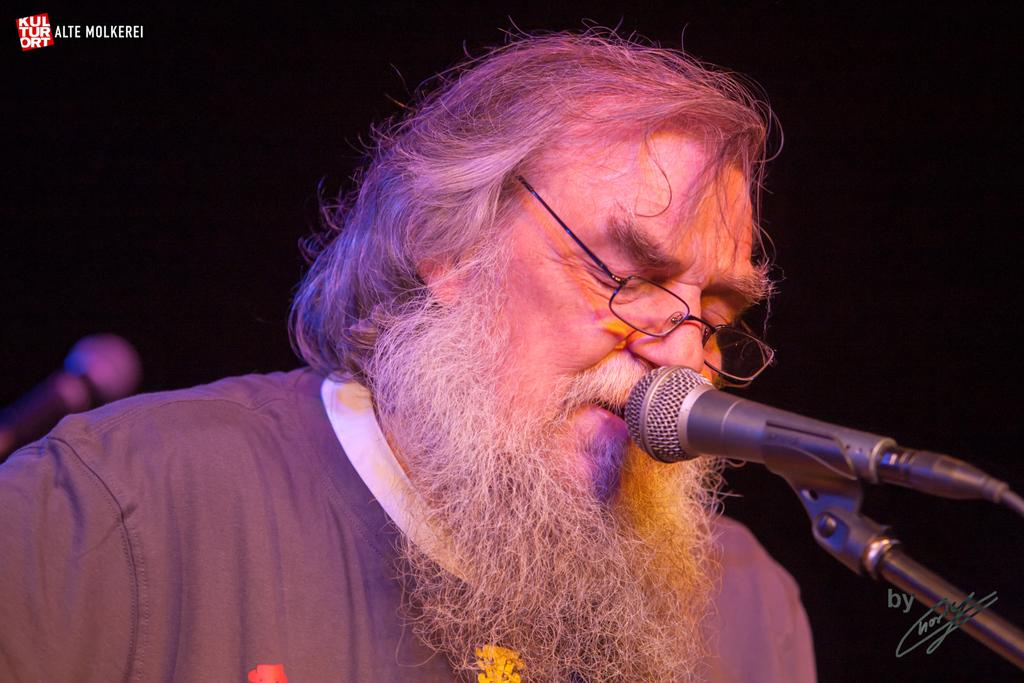Who or what is present in the image? There is a person in the image. Can you describe the person's appearance? The person is wearing spectacles. What object can be seen near the person? There is a microphone in the image. How would you describe the background of the image? The background of the image is blurred. What type of grain is visible in the image? There is no grain present in the image. What action is the person performing in the image? The provided facts do not mention any specific action being performed by the person in the image. 